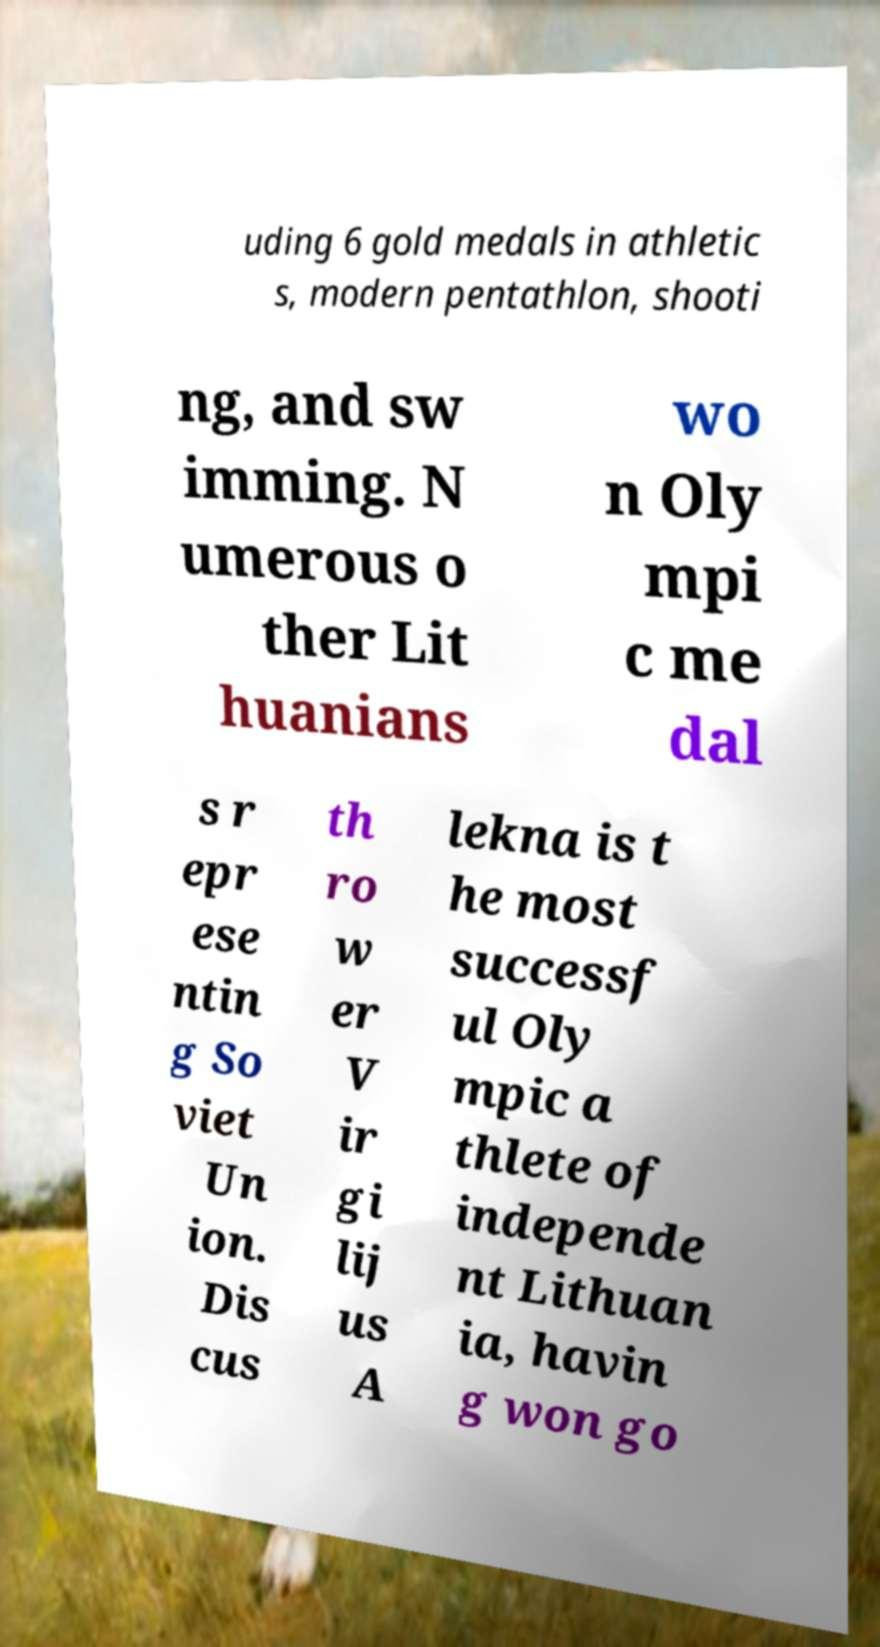Can you read and provide the text displayed in the image?This photo seems to have some interesting text. Can you extract and type it out for me? uding 6 gold medals in athletic s, modern pentathlon, shooti ng, and sw imming. N umerous o ther Lit huanians wo n Oly mpi c me dal s r epr ese ntin g So viet Un ion. Dis cus th ro w er V ir gi lij us A lekna is t he most successf ul Oly mpic a thlete of independe nt Lithuan ia, havin g won go 